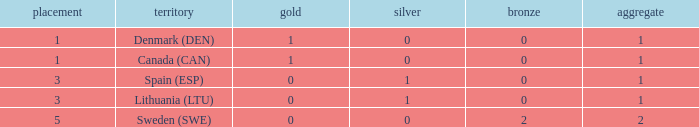Could you help me parse every detail presented in this table? {'header': ['placement', 'territory', 'gold', 'silver', 'bronze', 'aggregate'], 'rows': [['1', 'Denmark (DEN)', '1', '0', '0', '1'], ['1', 'Canada (CAN)', '1', '0', '0', '1'], ['3', 'Spain (ESP)', '0', '1', '0', '1'], ['3', 'Lithuania (LTU)', '0', '1', '0', '1'], ['5', 'Sweden (SWE)', '0', '0', '2', '2']]} What is the total when there were less than 0 bronze? 0.0. 